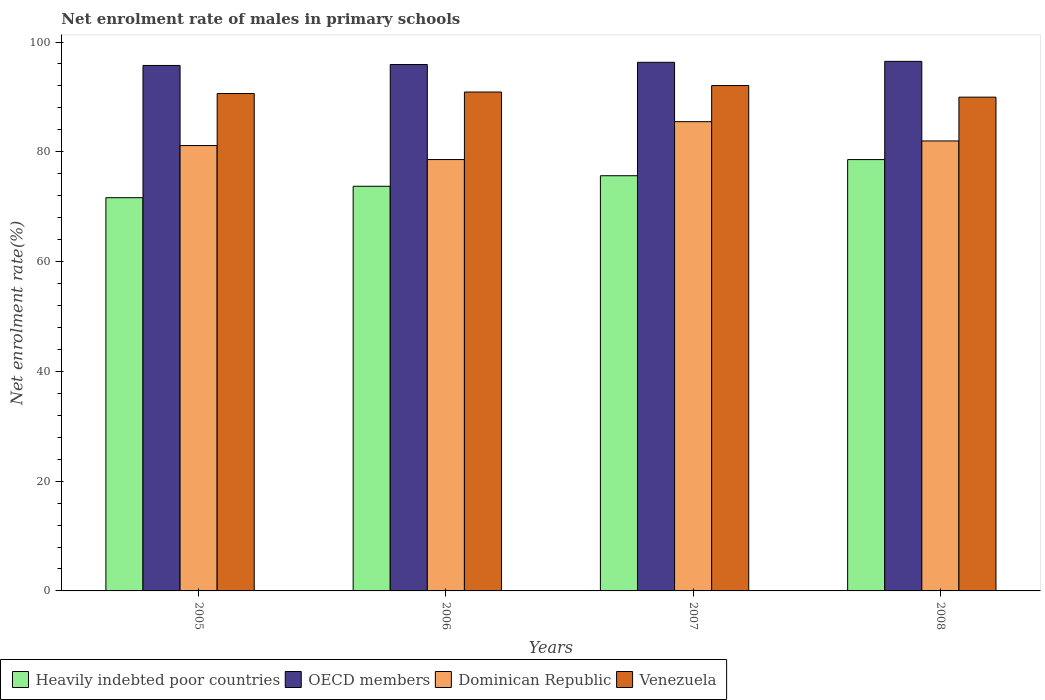How many different coloured bars are there?
Keep it short and to the point. 4. Are the number of bars on each tick of the X-axis equal?
Offer a terse response. Yes. In how many cases, is the number of bars for a given year not equal to the number of legend labels?
Your response must be concise. 0. What is the net enrolment rate of males in primary schools in OECD members in 2007?
Your answer should be compact. 96.31. Across all years, what is the maximum net enrolment rate of males in primary schools in Heavily indebted poor countries?
Provide a succinct answer. 78.59. Across all years, what is the minimum net enrolment rate of males in primary schools in OECD members?
Your answer should be very brief. 95.73. In which year was the net enrolment rate of males in primary schools in Venezuela minimum?
Provide a short and direct response. 2008. What is the total net enrolment rate of males in primary schools in Venezuela in the graph?
Provide a short and direct response. 363.55. What is the difference between the net enrolment rate of males in primary schools in OECD members in 2005 and that in 2006?
Your answer should be compact. -0.17. What is the difference between the net enrolment rate of males in primary schools in OECD members in 2007 and the net enrolment rate of males in primary schools in Heavily indebted poor countries in 2005?
Your response must be concise. 24.67. What is the average net enrolment rate of males in primary schools in Dominican Republic per year?
Your answer should be compact. 81.8. In the year 2007, what is the difference between the net enrolment rate of males in primary schools in OECD members and net enrolment rate of males in primary schools in Dominican Republic?
Keep it short and to the point. 10.81. In how many years, is the net enrolment rate of males in primary schools in Venezuela greater than 20 %?
Provide a short and direct response. 4. What is the ratio of the net enrolment rate of males in primary schools in Dominican Republic in 2007 to that in 2008?
Keep it short and to the point. 1.04. Is the net enrolment rate of males in primary schools in Venezuela in 2006 less than that in 2007?
Offer a very short reply. Yes. Is the difference between the net enrolment rate of males in primary schools in OECD members in 2005 and 2007 greater than the difference between the net enrolment rate of males in primary schools in Dominican Republic in 2005 and 2007?
Offer a terse response. Yes. What is the difference between the highest and the second highest net enrolment rate of males in primary schools in Heavily indebted poor countries?
Keep it short and to the point. 2.94. What is the difference between the highest and the lowest net enrolment rate of males in primary schools in Dominican Republic?
Offer a terse response. 6.9. Is it the case that in every year, the sum of the net enrolment rate of males in primary schools in Heavily indebted poor countries and net enrolment rate of males in primary schools in Venezuela is greater than the sum of net enrolment rate of males in primary schools in Dominican Republic and net enrolment rate of males in primary schools in OECD members?
Your response must be concise. No. What does the 3rd bar from the left in 2006 represents?
Your answer should be compact. Dominican Republic. What does the 4th bar from the right in 2007 represents?
Provide a succinct answer. Heavily indebted poor countries. Is it the case that in every year, the sum of the net enrolment rate of males in primary schools in OECD members and net enrolment rate of males in primary schools in Dominican Republic is greater than the net enrolment rate of males in primary schools in Heavily indebted poor countries?
Give a very brief answer. Yes. How many bars are there?
Your answer should be very brief. 16. Are all the bars in the graph horizontal?
Your answer should be compact. No. How many years are there in the graph?
Ensure brevity in your answer.  4. Are the values on the major ticks of Y-axis written in scientific E-notation?
Offer a terse response. No. Does the graph contain grids?
Provide a short and direct response. No. Where does the legend appear in the graph?
Your answer should be compact. Bottom left. How are the legend labels stacked?
Make the answer very short. Horizontal. What is the title of the graph?
Keep it short and to the point. Net enrolment rate of males in primary schools. What is the label or title of the X-axis?
Make the answer very short. Years. What is the label or title of the Y-axis?
Offer a terse response. Net enrolment rate(%). What is the Net enrolment rate(%) of Heavily indebted poor countries in 2005?
Your answer should be very brief. 71.64. What is the Net enrolment rate(%) in OECD members in 2005?
Your response must be concise. 95.73. What is the Net enrolment rate(%) of Dominican Republic in 2005?
Your answer should be very brief. 81.14. What is the Net enrolment rate(%) in Venezuela in 2005?
Offer a very short reply. 90.62. What is the Net enrolment rate(%) in Heavily indebted poor countries in 2006?
Provide a succinct answer. 73.72. What is the Net enrolment rate(%) of OECD members in 2006?
Make the answer very short. 95.9. What is the Net enrolment rate(%) in Dominican Republic in 2006?
Your response must be concise. 78.59. What is the Net enrolment rate(%) in Venezuela in 2006?
Give a very brief answer. 90.89. What is the Net enrolment rate(%) of Heavily indebted poor countries in 2007?
Make the answer very short. 75.65. What is the Net enrolment rate(%) in OECD members in 2007?
Offer a very short reply. 96.31. What is the Net enrolment rate(%) of Dominican Republic in 2007?
Keep it short and to the point. 85.49. What is the Net enrolment rate(%) of Venezuela in 2007?
Your answer should be compact. 92.07. What is the Net enrolment rate(%) of Heavily indebted poor countries in 2008?
Your response must be concise. 78.59. What is the Net enrolment rate(%) in OECD members in 2008?
Your answer should be very brief. 96.48. What is the Net enrolment rate(%) of Dominican Republic in 2008?
Provide a short and direct response. 81.98. What is the Net enrolment rate(%) of Venezuela in 2008?
Your answer should be compact. 89.96. Across all years, what is the maximum Net enrolment rate(%) of Heavily indebted poor countries?
Offer a very short reply. 78.59. Across all years, what is the maximum Net enrolment rate(%) in OECD members?
Your response must be concise. 96.48. Across all years, what is the maximum Net enrolment rate(%) in Dominican Republic?
Provide a succinct answer. 85.49. Across all years, what is the maximum Net enrolment rate(%) in Venezuela?
Offer a very short reply. 92.07. Across all years, what is the minimum Net enrolment rate(%) in Heavily indebted poor countries?
Keep it short and to the point. 71.64. Across all years, what is the minimum Net enrolment rate(%) in OECD members?
Your response must be concise. 95.73. Across all years, what is the minimum Net enrolment rate(%) of Dominican Republic?
Provide a short and direct response. 78.59. Across all years, what is the minimum Net enrolment rate(%) in Venezuela?
Your answer should be very brief. 89.96. What is the total Net enrolment rate(%) of Heavily indebted poor countries in the graph?
Give a very brief answer. 299.6. What is the total Net enrolment rate(%) in OECD members in the graph?
Your answer should be compact. 384.43. What is the total Net enrolment rate(%) in Dominican Republic in the graph?
Your answer should be very brief. 327.21. What is the total Net enrolment rate(%) of Venezuela in the graph?
Give a very brief answer. 363.55. What is the difference between the Net enrolment rate(%) in Heavily indebted poor countries in 2005 and that in 2006?
Your answer should be compact. -2.08. What is the difference between the Net enrolment rate(%) of OECD members in 2005 and that in 2006?
Give a very brief answer. -0.17. What is the difference between the Net enrolment rate(%) in Dominican Republic in 2005 and that in 2006?
Provide a short and direct response. 2.55. What is the difference between the Net enrolment rate(%) of Venezuela in 2005 and that in 2006?
Your response must be concise. -0.28. What is the difference between the Net enrolment rate(%) in Heavily indebted poor countries in 2005 and that in 2007?
Keep it short and to the point. -4. What is the difference between the Net enrolment rate(%) in OECD members in 2005 and that in 2007?
Offer a very short reply. -0.57. What is the difference between the Net enrolment rate(%) in Dominican Republic in 2005 and that in 2007?
Give a very brief answer. -4.35. What is the difference between the Net enrolment rate(%) of Venezuela in 2005 and that in 2007?
Offer a terse response. -1.45. What is the difference between the Net enrolment rate(%) in Heavily indebted poor countries in 2005 and that in 2008?
Your response must be concise. -6.95. What is the difference between the Net enrolment rate(%) of OECD members in 2005 and that in 2008?
Your answer should be compact. -0.75. What is the difference between the Net enrolment rate(%) of Dominican Republic in 2005 and that in 2008?
Make the answer very short. -0.84. What is the difference between the Net enrolment rate(%) in Venezuela in 2005 and that in 2008?
Keep it short and to the point. 0.66. What is the difference between the Net enrolment rate(%) in Heavily indebted poor countries in 2006 and that in 2007?
Ensure brevity in your answer.  -1.92. What is the difference between the Net enrolment rate(%) in OECD members in 2006 and that in 2007?
Offer a terse response. -0.4. What is the difference between the Net enrolment rate(%) in Dominican Republic in 2006 and that in 2007?
Give a very brief answer. -6.9. What is the difference between the Net enrolment rate(%) in Venezuela in 2006 and that in 2007?
Ensure brevity in your answer.  -1.18. What is the difference between the Net enrolment rate(%) in Heavily indebted poor countries in 2006 and that in 2008?
Your answer should be compact. -4.86. What is the difference between the Net enrolment rate(%) in OECD members in 2006 and that in 2008?
Your answer should be compact. -0.58. What is the difference between the Net enrolment rate(%) in Dominican Republic in 2006 and that in 2008?
Make the answer very short. -3.39. What is the difference between the Net enrolment rate(%) in Venezuela in 2006 and that in 2008?
Your response must be concise. 0.93. What is the difference between the Net enrolment rate(%) of Heavily indebted poor countries in 2007 and that in 2008?
Provide a succinct answer. -2.94. What is the difference between the Net enrolment rate(%) of OECD members in 2007 and that in 2008?
Give a very brief answer. -0.18. What is the difference between the Net enrolment rate(%) in Dominican Republic in 2007 and that in 2008?
Offer a very short reply. 3.51. What is the difference between the Net enrolment rate(%) in Venezuela in 2007 and that in 2008?
Provide a short and direct response. 2.11. What is the difference between the Net enrolment rate(%) in Heavily indebted poor countries in 2005 and the Net enrolment rate(%) in OECD members in 2006?
Provide a short and direct response. -24.26. What is the difference between the Net enrolment rate(%) of Heavily indebted poor countries in 2005 and the Net enrolment rate(%) of Dominican Republic in 2006?
Your answer should be compact. -6.95. What is the difference between the Net enrolment rate(%) in Heavily indebted poor countries in 2005 and the Net enrolment rate(%) in Venezuela in 2006?
Keep it short and to the point. -19.25. What is the difference between the Net enrolment rate(%) in OECD members in 2005 and the Net enrolment rate(%) in Dominican Republic in 2006?
Provide a succinct answer. 17.14. What is the difference between the Net enrolment rate(%) of OECD members in 2005 and the Net enrolment rate(%) of Venezuela in 2006?
Make the answer very short. 4.84. What is the difference between the Net enrolment rate(%) in Dominican Republic in 2005 and the Net enrolment rate(%) in Venezuela in 2006?
Make the answer very short. -9.75. What is the difference between the Net enrolment rate(%) in Heavily indebted poor countries in 2005 and the Net enrolment rate(%) in OECD members in 2007?
Your response must be concise. -24.67. What is the difference between the Net enrolment rate(%) in Heavily indebted poor countries in 2005 and the Net enrolment rate(%) in Dominican Republic in 2007?
Ensure brevity in your answer.  -13.85. What is the difference between the Net enrolment rate(%) in Heavily indebted poor countries in 2005 and the Net enrolment rate(%) in Venezuela in 2007?
Give a very brief answer. -20.43. What is the difference between the Net enrolment rate(%) in OECD members in 2005 and the Net enrolment rate(%) in Dominican Republic in 2007?
Your answer should be very brief. 10.24. What is the difference between the Net enrolment rate(%) in OECD members in 2005 and the Net enrolment rate(%) in Venezuela in 2007?
Provide a short and direct response. 3.66. What is the difference between the Net enrolment rate(%) of Dominican Republic in 2005 and the Net enrolment rate(%) of Venezuela in 2007?
Offer a very short reply. -10.93. What is the difference between the Net enrolment rate(%) in Heavily indebted poor countries in 2005 and the Net enrolment rate(%) in OECD members in 2008?
Offer a very short reply. -24.84. What is the difference between the Net enrolment rate(%) in Heavily indebted poor countries in 2005 and the Net enrolment rate(%) in Dominican Republic in 2008?
Offer a very short reply. -10.34. What is the difference between the Net enrolment rate(%) of Heavily indebted poor countries in 2005 and the Net enrolment rate(%) of Venezuela in 2008?
Your answer should be very brief. -18.32. What is the difference between the Net enrolment rate(%) in OECD members in 2005 and the Net enrolment rate(%) in Dominican Republic in 2008?
Provide a succinct answer. 13.75. What is the difference between the Net enrolment rate(%) in OECD members in 2005 and the Net enrolment rate(%) in Venezuela in 2008?
Provide a short and direct response. 5.77. What is the difference between the Net enrolment rate(%) in Dominican Republic in 2005 and the Net enrolment rate(%) in Venezuela in 2008?
Offer a terse response. -8.82. What is the difference between the Net enrolment rate(%) in Heavily indebted poor countries in 2006 and the Net enrolment rate(%) in OECD members in 2007?
Your response must be concise. -22.58. What is the difference between the Net enrolment rate(%) in Heavily indebted poor countries in 2006 and the Net enrolment rate(%) in Dominican Republic in 2007?
Offer a terse response. -11.77. What is the difference between the Net enrolment rate(%) of Heavily indebted poor countries in 2006 and the Net enrolment rate(%) of Venezuela in 2007?
Ensure brevity in your answer.  -18.35. What is the difference between the Net enrolment rate(%) of OECD members in 2006 and the Net enrolment rate(%) of Dominican Republic in 2007?
Your response must be concise. 10.41. What is the difference between the Net enrolment rate(%) in OECD members in 2006 and the Net enrolment rate(%) in Venezuela in 2007?
Make the answer very short. 3.83. What is the difference between the Net enrolment rate(%) of Dominican Republic in 2006 and the Net enrolment rate(%) of Venezuela in 2007?
Your answer should be compact. -13.48. What is the difference between the Net enrolment rate(%) of Heavily indebted poor countries in 2006 and the Net enrolment rate(%) of OECD members in 2008?
Offer a very short reply. -22.76. What is the difference between the Net enrolment rate(%) in Heavily indebted poor countries in 2006 and the Net enrolment rate(%) in Dominican Republic in 2008?
Ensure brevity in your answer.  -8.26. What is the difference between the Net enrolment rate(%) in Heavily indebted poor countries in 2006 and the Net enrolment rate(%) in Venezuela in 2008?
Make the answer very short. -16.24. What is the difference between the Net enrolment rate(%) in OECD members in 2006 and the Net enrolment rate(%) in Dominican Republic in 2008?
Your response must be concise. 13.92. What is the difference between the Net enrolment rate(%) of OECD members in 2006 and the Net enrolment rate(%) of Venezuela in 2008?
Keep it short and to the point. 5.94. What is the difference between the Net enrolment rate(%) of Dominican Republic in 2006 and the Net enrolment rate(%) of Venezuela in 2008?
Your answer should be very brief. -11.37. What is the difference between the Net enrolment rate(%) of Heavily indebted poor countries in 2007 and the Net enrolment rate(%) of OECD members in 2008?
Provide a succinct answer. -20.84. What is the difference between the Net enrolment rate(%) of Heavily indebted poor countries in 2007 and the Net enrolment rate(%) of Dominican Republic in 2008?
Provide a succinct answer. -6.33. What is the difference between the Net enrolment rate(%) of Heavily indebted poor countries in 2007 and the Net enrolment rate(%) of Venezuela in 2008?
Your answer should be compact. -14.32. What is the difference between the Net enrolment rate(%) of OECD members in 2007 and the Net enrolment rate(%) of Dominican Republic in 2008?
Offer a terse response. 14.33. What is the difference between the Net enrolment rate(%) of OECD members in 2007 and the Net enrolment rate(%) of Venezuela in 2008?
Offer a very short reply. 6.35. What is the difference between the Net enrolment rate(%) of Dominican Republic in 2007 and the Net enrolment rate(%) of Venezuela in 2008?
Provide a short and direct response. -4.47. What is the average Net enrolment rate(%) of Heavily indebted poor countries per year?
Your response must be concise. 74.9. What is the average Net enrolment rate(%) in OECD members per year?
Your response must be concise. 96.11. What is the average Net enrolment rate(%) in Dominican Republic per year?
Make the answer very short. 81.8. What is the average Net enrolment rate(%) of Venezuela per year?
Provide a succinct answer. 90.89. In the year 2005, what is the difference between the Net enrolment rate(%) of Heavily indebted poor countries and Net enrolment rate(%) of OECD members?
Offer a terse response. -24.09. In the year 2005, what is the difference between the Net enrolment rate(%) of Heavily indebted poor countries and Net enrolment rate(%) of Dominican Republic?
Make the answer very short. -9.5. In the year 2005, what is the difference between the Net enrolment rate(%) of Heavily indebted poor countries and Net enrolment rate(%) of Venezuela?
Your answer should be compact. -18.98. In the year 2005, what is the difference between the Net enrolment rate(%) in OECD members and Net enrolment rate(%) in Dominican Republic?
Your answer should be compact. 14.59. In the year 2005, what is the difference between the Net enrolment rate(%) of OECD members and Net enrolment rate(%) of Venezuela?
Your answer should be compact. 5.11. In the year 2005, what is the difference between the Net enrolment rate(%) of Dominican Republic and Net enrolment rate(%) of Venezuela?
Provide a succinct answer. -9.48. In the year 2006, what is the difference between the Net enrolment rate(%) in Heavily indebted poor countries and Net enrolment rate(%) in OECD members?
Offer a very short reply. -22.18. In the year 2006, what is the difference between the Net enrolment rate(%) in Heavily indebted poor countries and Net enrolment rate(%) in Dominican Republic?
Offer a very short reply. -4.87. In the year 2006, what is the difference between the Net enrolment rate(%) in Heavily indebted poor countries and Net enrolment rate(%) in Venezuela?
Provide a succinct answer. -17.17. In the year 2006, what is the difference between the Net enrolment rate(%) of OECD members and Net enrolment rate(%) of Dominican Republic?
Make the answer very short. 17.32. In the year 2006, what is the difference between the Net enrolment rate(%) of OECD members and Net enrolment rate(%) of Venezuela?
Ensure brevity in your answer.  5.01. In the year 2006, what is the difference between the Net enrolment rate(%) in Dominican Republic and Net enrolment rate(%) in Venezuela?
Keep it short and to the point. -12.3. In the year 2007, what is the difference between the Net enrolment rate(%) in Heavily indebted poor countries and Net enrolment rate(%) in OECD members?
Your answer should be compact. -20.66. In the year 2007, what is the difference between the Net enrolment rate(%) in Heavily indebted poor countries and Net enrolment rate(%) in Dominican Republic?
Your answer should be very brief. -9.85. In the year 2007, what is the difference between the Net enrolment rate(%) of Heavily indebted poor countries and Net enrolment rate(%) of Venezuela?
Give a very brief answer. -16.43. In the year 2007, what is the difference between the Net enrolment rate(%) in OECD members and Net enrolment rate(%) in Dominican Republic?
Provide a short and direct response. 10.81. In the year 2007, what is the difference between the Net enrolment rate(%) in OECD members and Net enrolment rate(%) in Venezuela?
Your answer should be compact. 4.24. In the year 2007, what is the difference between the Net enrolment rate(%) in Dominican Republic and Net enrolment rate(%) in Venezuela?
Provide a short and direct response. -6.58. In the year 2008, what is the difference between the Net enrolment rate(%) of Heavily indebted poor countries and Net enrolment rate(%) of OECD members?
Your answer should be compact. -17.9. In the year 2008, what is the difference between the Net enrolment rate(%) in Heavily indebted poor countries and Net enrolment rate(%) in Dominican Republic?
Keep it short and to the point. -3.39. In the year 2008, what is the difference between the Net enrolment rate(%) in Heavily indebted poor countries and Net enrolment rate(%) in Venezuela?
Your answer should be compact. -11.37. In the year 2008, what is the difference between the Net enrolment rate(%) of OECD members and Net enrolment rate(%) of Dominican Republic?
Keep it short and to the point. 14.5. In the year 2008, what is the difference between the Net enrolment rate(%) in OECD members and Net enrolment rate(%) in Venezuela?
Provide a succinct answer. 6.52. In the year 2008, what is the difference between the Net enrolment rate(%) of Dominican Republic and Net enrolment rate(%) of Venezuela?
Offer a terse response. -7.98. What is the ratio of the Net enrolment rate(%) of Heavily indebted poor countries in 2005 to that in 2006?
Your response must be concise. 0.97. What is the ratio of the Net enrolment rate(%) in OECD members in 2005 to that in 2006?
Provide a succinct answer. 1. What is the ratio of the Net enrolment rate(%) in Dominican Republic in 2005 to that in 2006?
Provide a succinct answer. 1.03. What is the ratio of the Net enrolment rate(%) in Venezuela in 2005 to that in 2006?
Keep it short and to the point. 1. What is the ratio of the Net enrolment rate(%) in Heavily indebted poor countries in 2005 to that in 2007?
Your answer should be compact. 0.95. What is the ratio of the Net enrolment rate(%) of Dominican Republic in 2005 to that in 2007?
Ensure brevity in your answer.  0.95. What is the ratio of the Net enrolment rate(%) of Venezuela in 2005 to that in 2007?
Make the answer very short. 0.98. What is the ratio of the Net enrolment rate(%) of Heavily indebted poor countries in 2005 to that in 2008?
Keep it short and to the point. 0.91. What is the ratio of the Net enrolment rate(%) in Venezuela in 2005 to that in 2008?
Provide a succinct answer. 1.01. What is the ratio of the Net enrolment rate(%) in Heavily indebted poor countries in 2006 to that in 2007?
Offer a terse response. 0.97. What is the ratio of the Net enrolment rate(%) in Dominican Republic in 2006 to that in 2007?
Offer a very short reply. 0.92. What is the ratio of the Net enrolment rate(%) in Venezuela in 2006 to that in 2007?
Your answer should be very brief. 0.99. What is the ratio of the Net enrolment rate(%) of Heavily indebted poor countries in 2006 to that in 2008?
Give a very brief answer. 0.94. What is the ratio of the Net enrolment rate(%) in Dominican Republic in 2006 to that in 2008?
Provide a succinct answer. 0.96. What is the ratio of the Net enrolment rate(%) of Venezuela in 2006 to that in 2008?
Offer a very short reply. 1.01. What is the ratio of the Net enrolment rate(%) in Heavily indebted poor countries in 2007 to that in 2008?
Your answer should be very brief. 0.96. What is the ratio of the Net enrolment rate(%) of Dominican Republic in 2007 to that in 2008?
Provide a succinct answer. 1.04. What is the ratio of the Net enrolment rate(%) in Venezuela in 2007 to that in 2008?
Make the answer very short. 1.02. What is the difference between the highest and the second highest Net enrolment rate(%) of Heavily indebted poor countries?
Your answer should be compact. 2.94. What is the difference between the highest and the second highest Net enrolment rate(%) in OECD members?
Give a very brief answer. 0.18. What is the difference between the highest and the second highest Net enrolment rate(%) in Dominican Republic?
Offer a terse response. 3.51. What is the difference between the highest and the second highest Net enrolment rate(%) in Venezuela?
Give a very brief answer. 1.18. What is the difference between the highest and the lowest Net enrolment rate(%) of Heavily indebted poor countries?
Your answer should be very brief. 6.95. What is the difference between the highest and the lowest Net enrolment rate(%) of OECD members?
Make the answer very short. 0.75. What is the difference between the highest and the lowest Net enrolment rate(%) in Dominican Republic?
Your answer should be very brief. 6.9. What is the difference between the highest and the lowest Net enrolment rate(%) of Venezuela?
Your response must be concise. 2.11. 